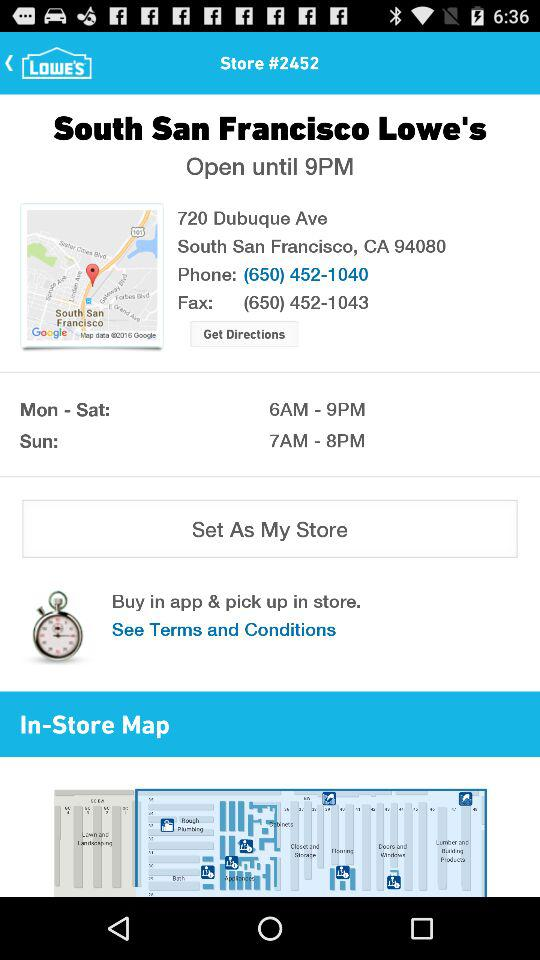What is the address of the store? The address is 720 Dubuque Ave, South San Francisco, CA 94080. 